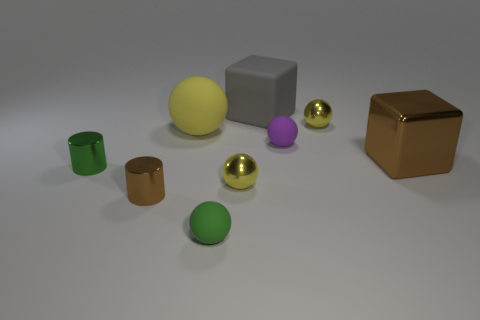Add 1 gray things. How many objects exist? 10 Subtract all green balls. How many balls are left? 4 Subtract all blocks. How many objects are left? 7 Subtract 1 cylinders. How many cylinders are left? 1 Subtract 0 yellow cubes. How many objects are left? 9 Subtract all brown cylinders. Subtract all gray cubes. How many cylinders are left? 1 Subtract all yellow blocks. How many red spheres are left? 0 Subtract all gray metal things. Subtract all yellow metallic objects. How many objects are left? 7 Add 2 small purple spheres. How many small purple spheres are left? 3 Add 8 big purple matte things. How many big purple matte things exist? 8 